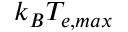<formula> <loc_0><loc_0><loc_500><loc_500>k _ { B } T _ { e , \max }</formula> 